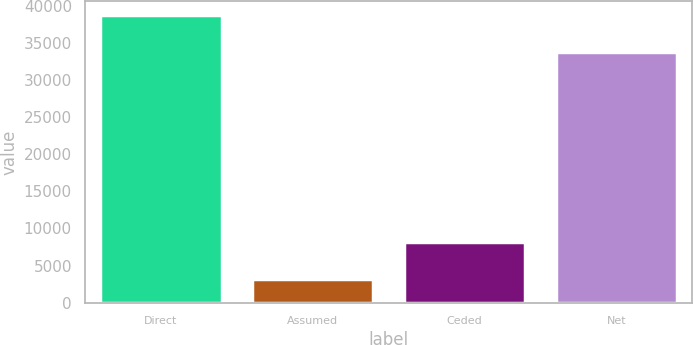Convert chart. <chart><loc_0><loc_0><loc_500><loc_500><bar_chart><fcel>Direct<fcel>Assumed<fcel>Ceded<fcel>Net<nl><fcel>38707<fcel>3258<fcel>8140<fcel>33825<nl></chart> 